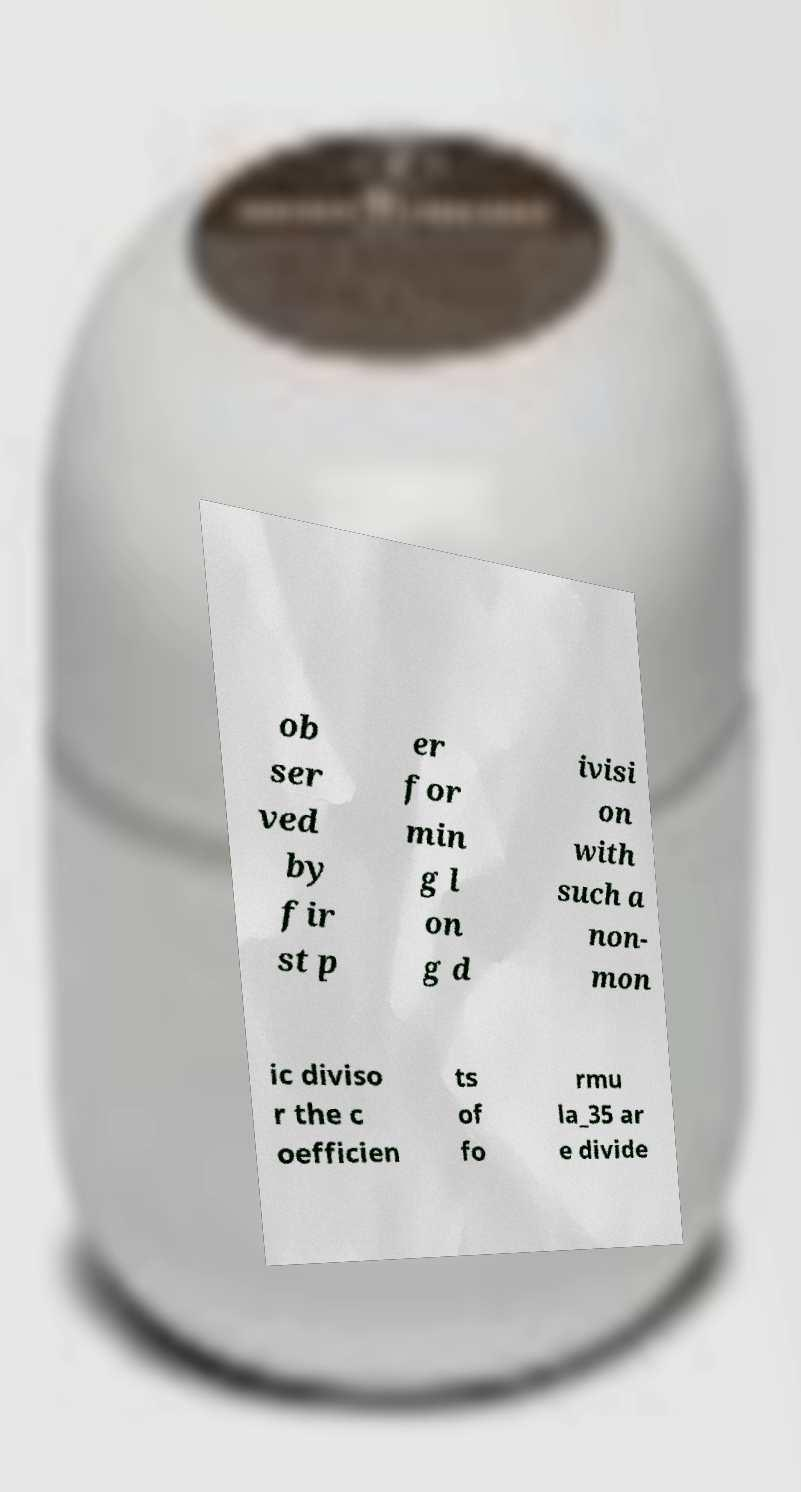Please identify and transcribe the text found in this image. ob ser ved by fir st p er for min g l on g d ivisi on with such a non- mon ic diviso r the c oefficien ts of fo rmu la_35 ar e divide 